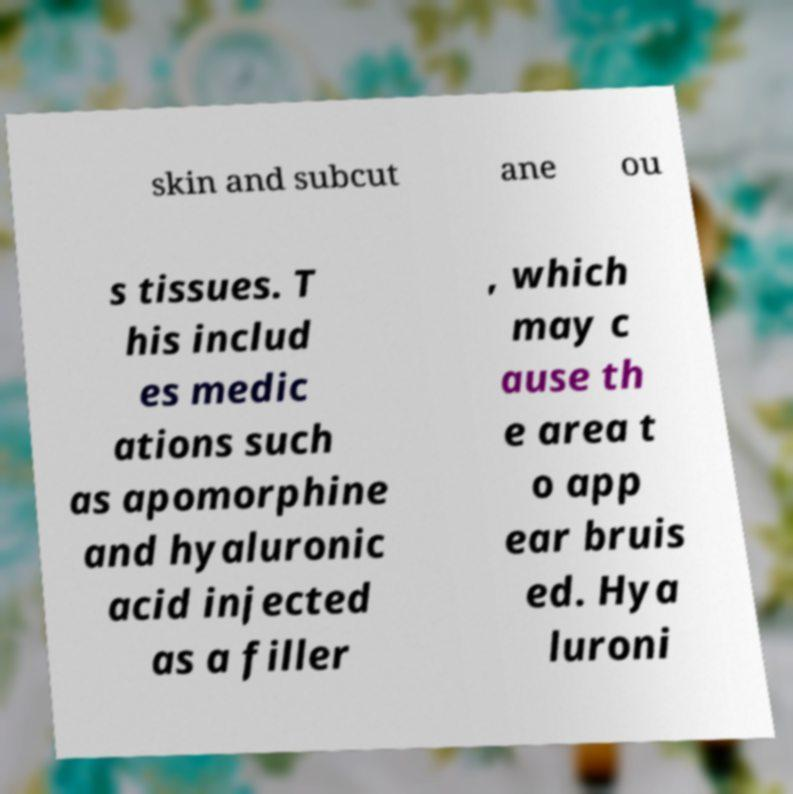Could you assist in decoding the text presented in this image and type it out clearly? skin and subcut ane ou s tissues. T his includ es medic ations such as apomorphine and hyaluronic acid injected as a filler , which may c ause th e area t o app ear bruis ed. Hya luroni 